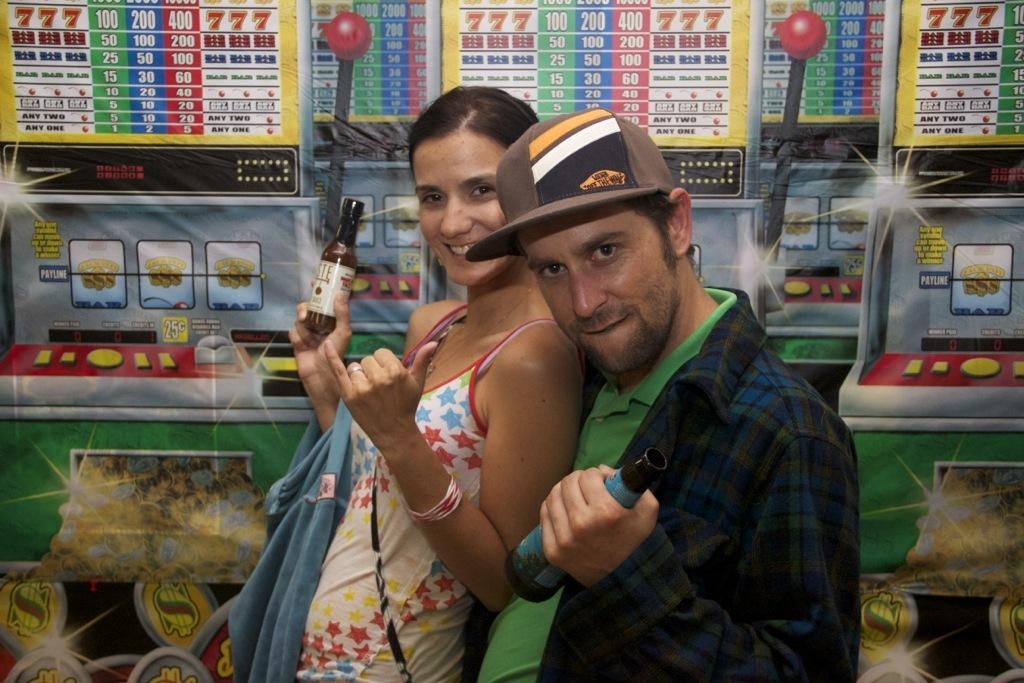Who is present in the image? There is a man and a woman in the image. What are the man and woman holding in the image? The man and woman are holding bottles in the image. What can be seen in the background of the image? There are pictures on the wall in the background of the image. What type of humor can be seen in the man's expression in the image? There is no indication of humor or any specific expression on the man's face in the image. 